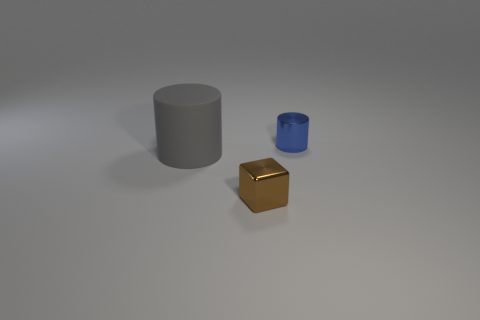Is there anything else that is the same size as the matte object?
Give a very brief answer. No. There is a object that is behind the large gray thing; what is its shape?
Give a very brief answer. Cylinder. What is the shape of the blue metallic object that is the same size as the metal cube?
Keep it short and to the point. Cylinder. What is the color of the tiny thing that is in front of the small thing behind the thing that is in front of the big cylinder?
Your response must be concise. Brown. Is the brown thing the same shape as the small blue thing?
Your answer should be very brief. No. Are there an equal number of metal things that are left of the tiny brown metal block and tiny blue objects?
Offer a terse response. No. How many other things are the same material as the small brown cube?
Ensure brevity in your answer.  1. Do the cylinder on the left side of the brown object and the metal thing that is in front of the blue cylinder have the same size?
Offer a terse response. No. How many objects are either small things that are in front of the big gray thing or metal things that are in front of the small blue thing?
Ensure brevity in your answer.  1. Is there anything else that has the same shape as the tiny brown metallic thing?
Your answer should be very brief. No. 